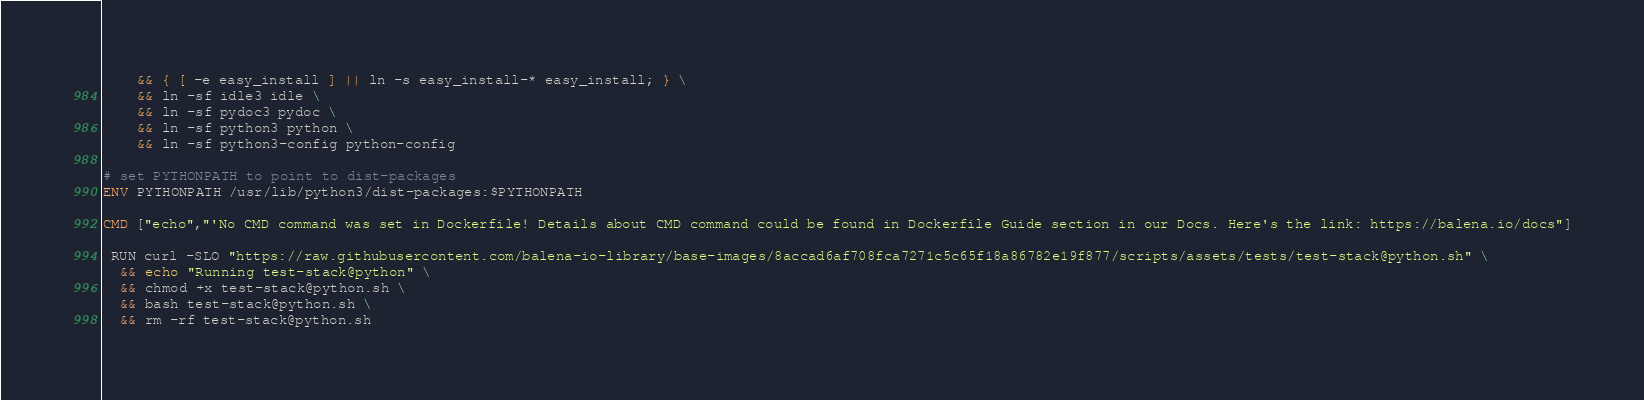Convert code to text. <code><loc_0><loc_0><loc_500><loc_500><_Dockerfile_>	&& { [ -e easy_install ] || ln -s easy_install-* easy_install; } \
	&& ln -sf idle3 idle \
	&& ln -sf pydoc3 pydoc \
	&& ln -sf python3 python \
	&& ln -sf python3-config python-config

# set PYTHONPATH to point to dist-packages
ENV PYTHONPATH /usr/lib/python3/dist-packages:$PYTHONPATH

CMD ["echo","'No CMD command was set in Dockerfile! Details about CMD command could be found in Dockerfile Guide section in our Docs. Here's the link: https://balena.io/docs"]

 RUN curl -SLO "https://raw.githubusercontent.com/balena-io-library/base-images/8accad6af708fca7271c5c65f18a86782e19f877/scripts/assets/tests/test-stack@python.sh" \
  && echo "Running test-stack@python" \
  && chmod +x test-stack@python.sh \
  && bash test-stack@python.sh \
  && rm -rf test-stack@python.sh 
</code> 